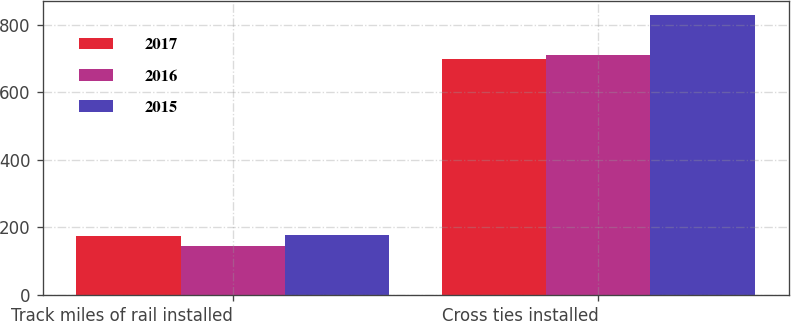Convert chart. <chart><loc_0><loc_0><loc_500><loc_500><stacked_bar_chart><ecel><fcel>Track miles of rail installed<fcel>Cross ties installed<nl><fcel>2017<fcel>174<fcel>699<nl><fcel>2016<fcel>146<fcel>711<nl><fcel>2015<fcel>177<fcel>829<nl></chart> 